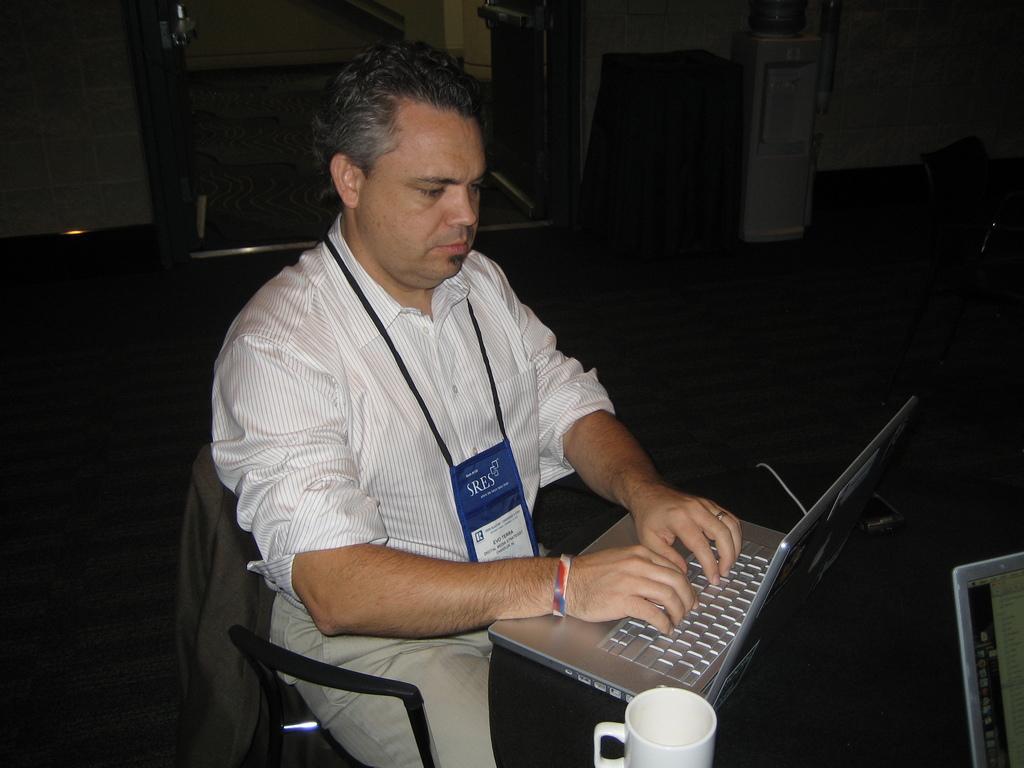Can you describe this image briefly? In the center of the image we can see a man sitting and there is a table. We can see laptops and a mug placed on the table. In the background there is a wall and a door. we can see stands. 